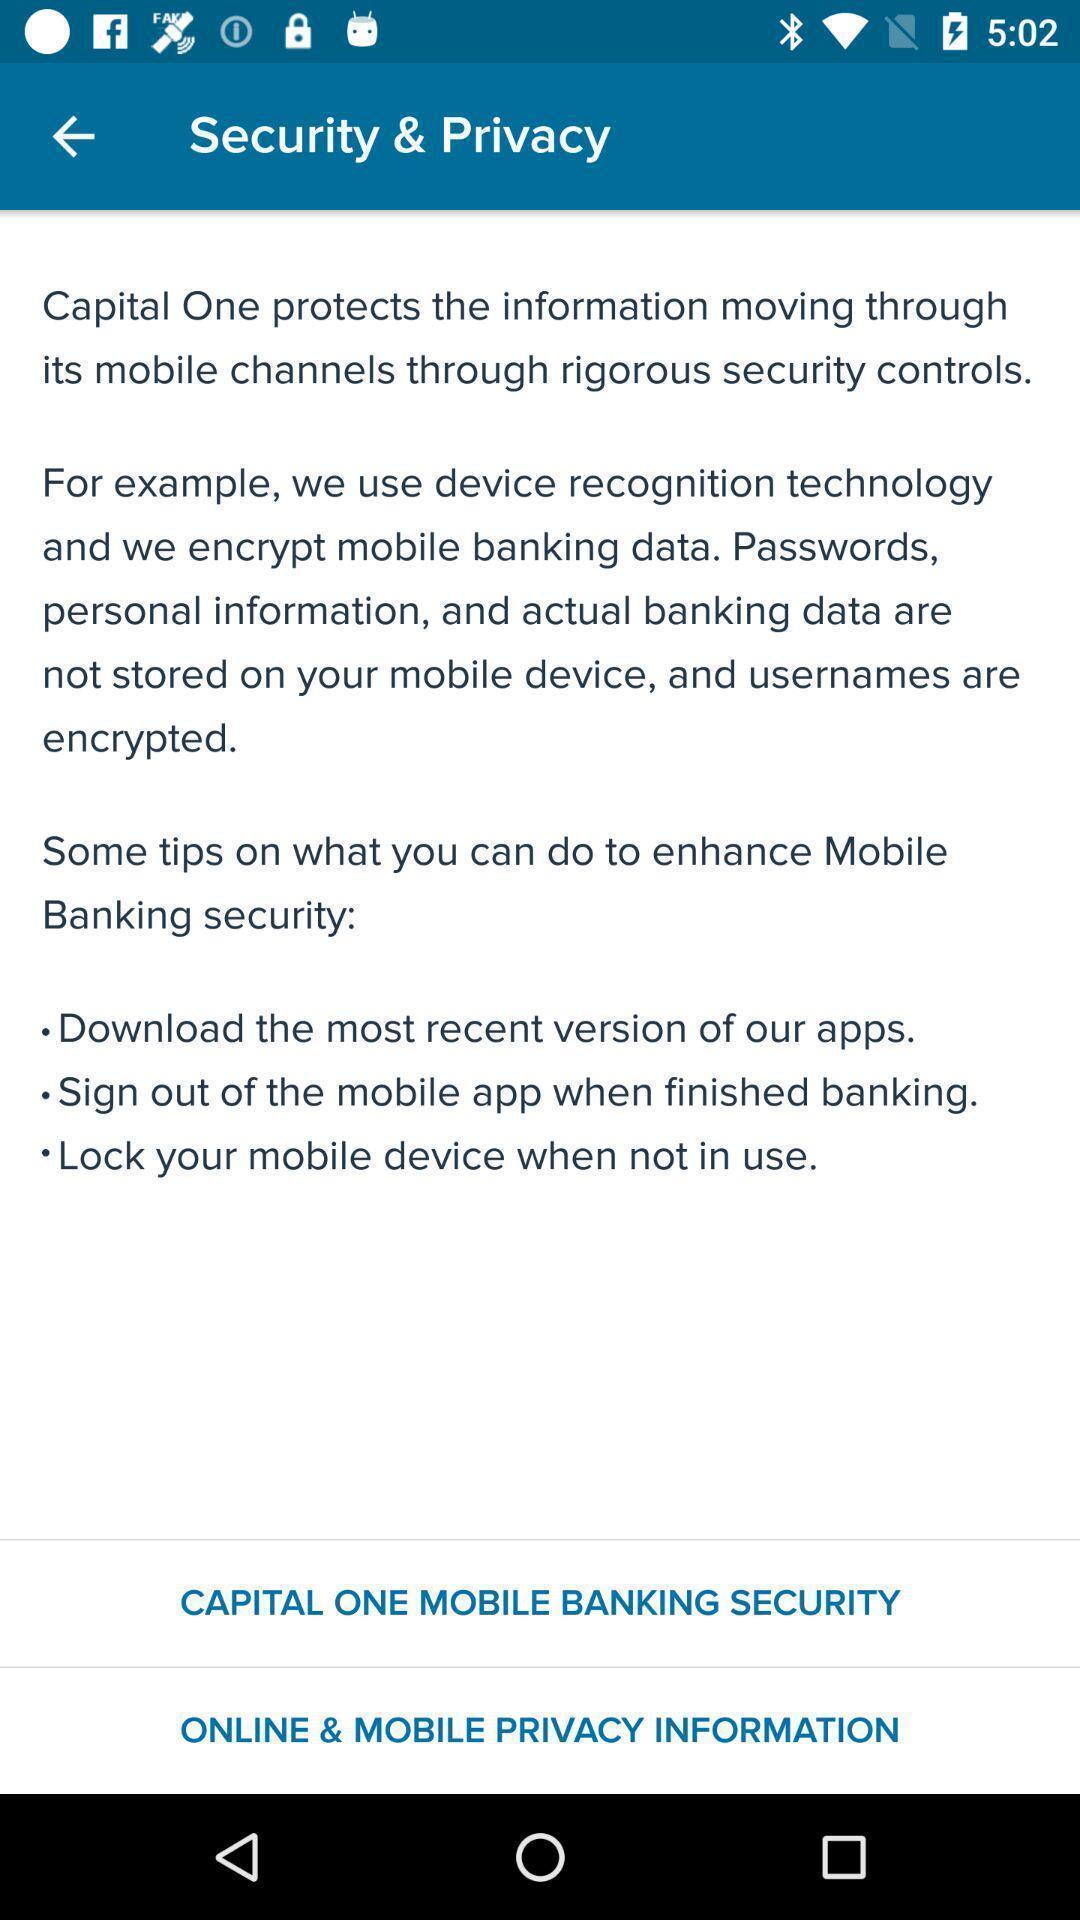Describe the visual elements of this screenshot. Page displaying security and privacy details. 